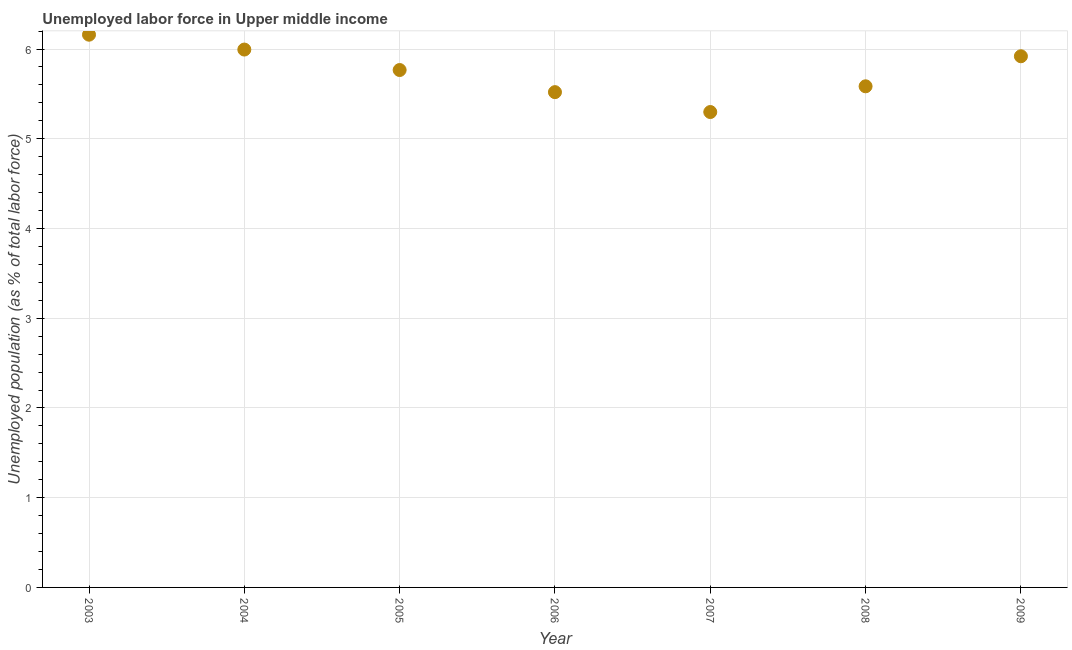What is the total unemployed population in 2008?
Your response must be concise. 5.58. Across all years, what is the maximum total unemployed population?
Your answer should be compact. 6.16. Across all years, what is the minimum total unemployed population?
Provide a short and direct response. 5.3. In which year was the total unemployed population maximum?
Ensure brevity in your answer.  2003. In which year was the total unemployed population minimum?
Provide a short and direct response. 2007. What is the sum of the total unemployed population?
Your answer should be compact. 40.24. What is the difference between the total unemployed population in 2006 and 2008?
Make the answer very short. -0.07. What is the average total unemployed population per year?
Your answer should be very brief. 5.75. What is the median total unemployed population?
Provide a succinct answer. 5.77. What is the ratio of the total unemployed population in 2003 to that in 2005?
Offer a very short reply. 1.07. Is the total unemployed population in 2005 less than that in 2008?
Ensure brevity in your answer.  No. What is the difference between the highest and the second highest total unemployed population?
Offer a very short reply. 0.17. What is the difference between the highest and the lowest total unemployed population?
Ensure brevity in your answer.  0.86. Does the total unemployed population monotonically increase over the years?
Your answer should be very brief. No. How many dotlines are there?
Your answer should be very brief. 1. How many years are there in the graph?
Provide a short and direct response. 7. Does the graph contain any zero values?
Your answer should be very brief. No. Does the graph contain grids?
Your answer should be very brief. Yes. What is the title of the graph?
Your answer should be compact. Unemployed labor force in Upper middle income. What is the label or title of the Y-axis?
Provide a succinct answer. Unemployed population (as % of total labor force). What is the Unemployed population (as % of total labor force) in 2003?
Offer a terse response. 6.16. What is the Unemployed population (as % of total labor force) in 2004?
Provide a succinct answer. 5.99. What is the Unemployed population (as % of total labor force) in 2005?
Provide a short and direct response. 5.77. What is the Unemployed population (as % of total labor force) in 2006?
Ensure brevity in your answer.  5.52. What is the Unemployed population (as % of total labor force) in 2007?
Provide a succinct answer. 5.3. What is the Unemployed population (as % of total labor force) in 2008?
Your response must be concise. 5.58. What is the Unemployed population (as % of total labor force) in 2009?
Keep it short and to the point. 5.92. What is the difference between the Unemployed population (as % of total labor force) in 2003 and 2004?
Your response must be concise. 0.17. What is the difference between the Unemployed population (as % of total labor force) in 2003 and 2005?
Give a very brief answer. 0.39. What is the difference between the Unemployed population (as % of total labor force) in 2003 and 2006?
Ensure brevity in your answer.  0.64. What is the difference between the Unemployed population (as % of total labor force) in 2003 and 2007?
Make the answer very short. 0.86. What is the difference between the Unemployed population (as % of total labor force) in 2003 and 2008?
Make the answer very short. 0.58. What is the difference between the Unemployed population (as % of total labor force) in 2003 and 2009?
Offer a terse response. 0.24. What is the difference between the Unemployed population (as % of total labor force) in 2004 and 2005?
Offer a terse response. 0.23. What is the difference between the Unemployed population (as % of total labor force) in 2004 and 2006?
Your response must be concise. 0.47. What is the difference between the Unemployed population (as % of total labor force) in 2004 and 2007?
Your answer should be very brief. 0.7. What is the difference between the Unemployed population (as % of total labor force) in 2004 and 2008?
Your answer should be very brief. 0.41. What is the difference between the Unemployed population (as % of total labor force) in 2004 and 2009?
Your response must be concise. 0.07. What is the difference between the Unemployed population (as % of total labor force) in 2005 and 2006?
Provide a short and direct response. 0.25. What is the difference between the Unemployed population (as % of total labor force) in 2005 and 2007?
Provide a succinct answer. 0.47. What is the difference between the Unemployed population (as % of total labor force) in 2005 and 2008?
Your response must be concise. 0.18. What is the difference between the Unemployed population (as % of total labor force) in 2005 and 2009?
Your answer should be very brief. -0.15. What is the difference between the Unemployed population (as % of total labor force) in 2006 and 2007?
Provide a succinct answer. 0.22. What is the difference between the Unemployed population (as % of total labor force) in 2006 and 2008?
Ensure brevity in your answer.  -0.07. What is the difference between the Unemployed population (as % of total labor force) in 2006 and 2009?
Offer a very short reply. -0.4. What is the difference between the Unemployed population (as % of total labor force) in 2007 and 2008?
Give a very brief answer. -0.29. What is the difference between the Unemployed population (as % of total labor force) in 2007 and 2009?
Provide a short and direct response. -0.62. What is the difference between the Unemployed population (as % of total labor force) in 2008 and 2009?
Your answer should be compact. -0.33. What is the ratio of the Unemployed population (as % of total labor force) in 2003 to that in 2004?
Provide a short and direct response. 1.03. What is the ratio of the Unemployed population (as % of total labor force) in 2003 to that in 2005?
Your answer should be very brief. 1.07. What is the ratio of the Unemployed population (as % of total labor force) in 2003 to that in 2006?
Give a very brief answer. 1.12. What is the ratio of the Unemployed population (as % of total labor force) in 2003 to that in 2007?
Keep it short and to the point. 1.16. What is the ratio of the Unemployed population (as % of total labor force) in 2003 to that in 2008?
Ensure brevity in your answer.  1.1. What is the ratio of the Unemployed population (as % of total labor force) in 2003 to that in 2009?
Your answer should be very brief. 1.04. What is the ratio of the Unemployed population (as % of total labor force) in 2004 to that in 2005?
Give a very brief answer. 1.04. What is the ratio of the Unemployed population (as % of total labor force) in 2004 to that in 2006?
Your answer should be very brief. 1.09. What is the ratio of the Unemployed population (as % of total labor force) in 2004 to that in 2007?
Provide a short and direct response. 1.13. What is the ratio of the Unemployed population (as % of total labor force) in 2004 to that in 2008?
Ensure brevity in your answer.  1.07. What is the ratio of the Unemployed population (as % of total labor force) in 2005 to that in 2006?
Your answer should be very brief. 1.04. What is the ratio of the Unemployed population (as % of total labor force) in 2005 to that in 2007?
Make the answer very short. 1.09. What is the ratio of the Unemployed population (as % of total labor force) in 2005 to that in 2008?
Give a very brief answer. 1.03. What is the ratio of the Unemployed population (as % of total labor force) in 2005 to that in 2009?
Your response must be concise. 0.97. What is the ratio of the Unemployed population (as % of total labor force) in 2006 to that in 2007?
Your response must be concise. 1.04. What is the ratio of the Unemployed population (as % of total labor force) in 2006 to that in 2009?
Provide a succinct answer. 0.93. What is the ratio of the Unemployed population (as % of total labor force) in 2007 to that in 2008?
Offer a very short reply. 0.95. What is the ratio of the Unemployed population (as % of total labor force) in 2007 to that in 2009?
Provide a succinct answer. 0.9. What is the ratio of the Unemployed population (as % of total labor force) in 2008 to that in 2009?
Offer a very short reply. 0.94. 